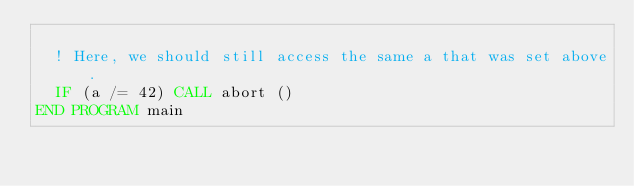<code> <loc_0><loc_0><loc_500><loc_500><_FORTRAN_>
  ! Here, we should still access the same a that was set above.
  IF (a /= 42) CALL abort ()
END PROGRAM main
</code> 